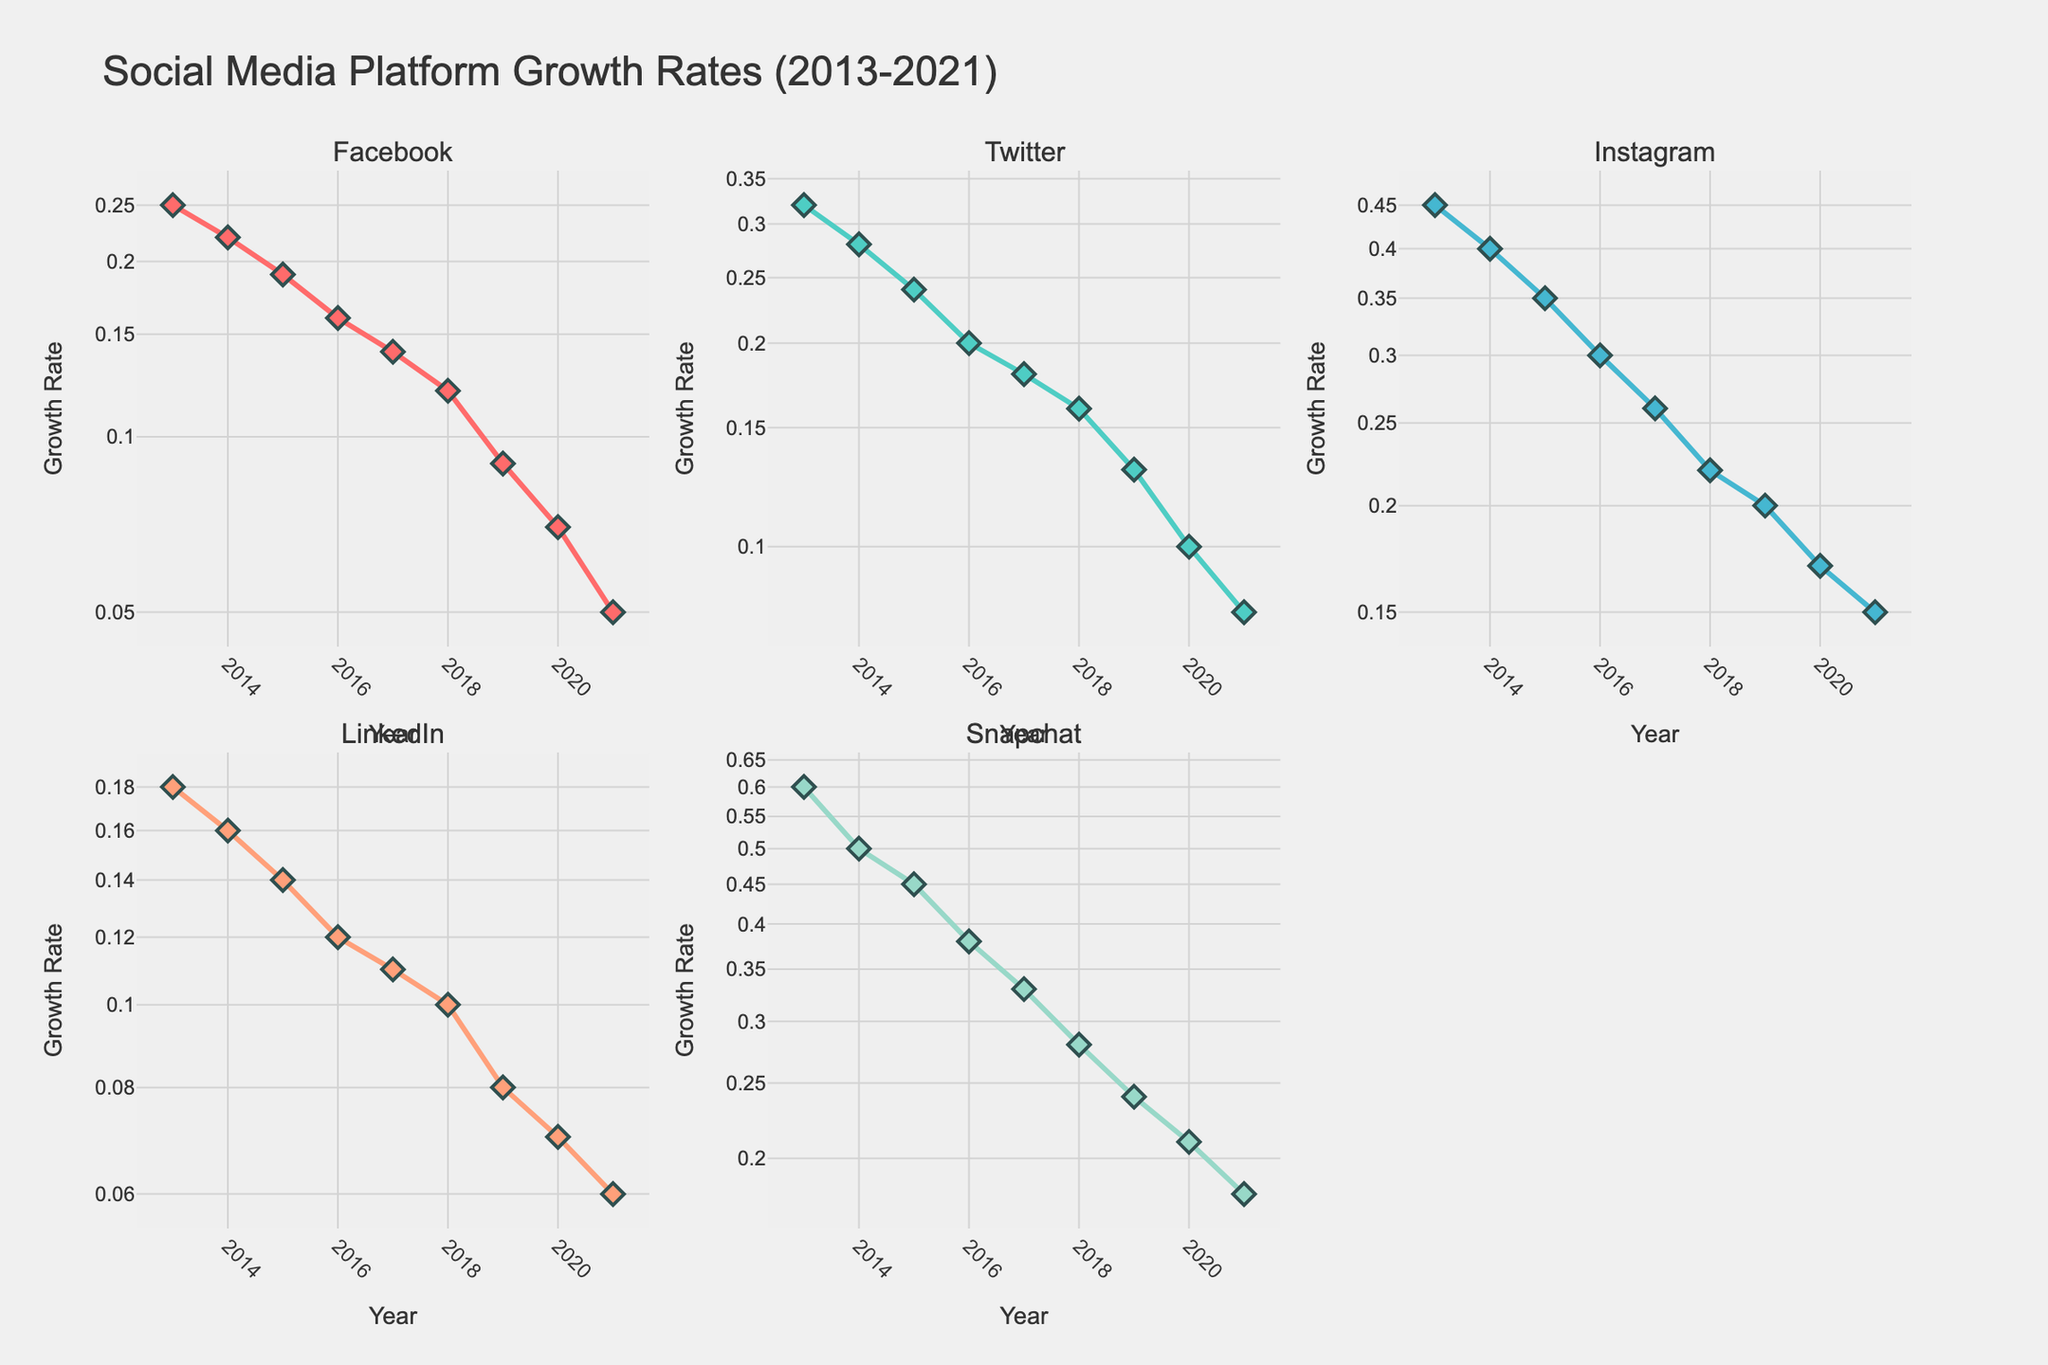What is the highest growth rate recorded for Snapchat? To determine the highest growth rate for Snapchat, observe the plot for Snapchat and identify the peak point on the graph. In 2013, Snapchat has the highest growth rate.
Answer: 0.60 What trend do you observe in Instagram's growth rate over the decade? Look at the Instagram subplot. The growth rate decreases steadily each year from 2013 to 2021.
Answer: Decreasing How does Facebook's growth rate in 2021 compare to LinkedIn's growth rate in 2021? Compare the points on the plots for Facebook and LinkedIn in 2021. Facebook has a growth rate of 0.05, while LinkedIn has a growth rate of 0.06.
Answer: LinkedIn's growth rate is higher Which year did Twitter experience the highest growth rate, and what was it? Inspect Twitter's subplot and find the highest point. The highest growth rate is in 2013.
Answer: 2013, 0.32 In which year did Instagram and Snapchat have the most similar growth rates, and what were their values? Look for years where the plot lines for Instagram and Snapchat are closest. In 2021, Instagram and Snapchat had similarly close growth rates of 0.15 and 0.18, respectively.
Answer: 2021, Instagram: 0.15, Snapchat: 0.18 What is the approximate growth rate for Facebook in 2015? Find Facebook's 2015 data point on the plot. The 2015 growth rate is around 0.19.
Answer: 0.19 Comparing the initial and final growth rates, which platform experienced the largest decrease? Calculate the difference between the first and last growth rates for each platform, then compare. Snapchat decreased from 0.60 to 0.18, a difference of 0.42, which is the largest.
Answer: Snapchat Observe the log scale on the y-axis. Why might a log scale be used for this data? The log scale can help handle the wide range of growth rates and emphasize percentage changes more effectively. It makes it easier to compare different growth rates visually.
Answer: To handle a wide range of growth rates Which social media platform had the steepest decline in growth rate between 2016 and 2017? Examine the plot segments between 2016 and 2017 for each platform. Look for the steepest slope drop. Snapchat's decline from 0.38 to 0.33 is the steepest.
Answer: Snapchat 